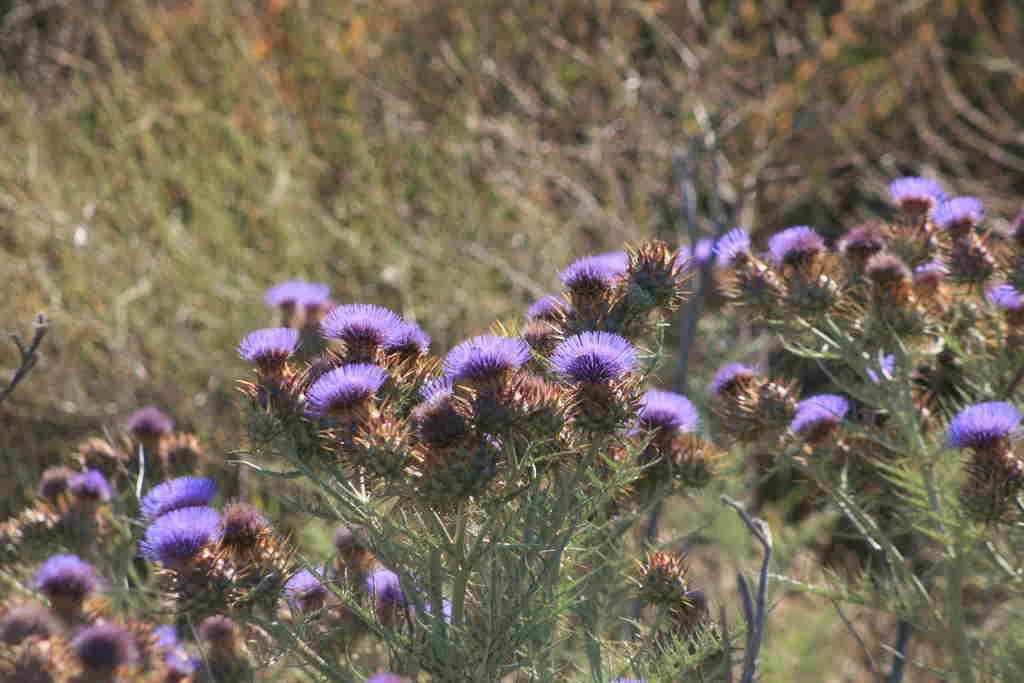What type of living organisms can be seen in the image? There are flowers and plants visible in the image. Can you describe the plants in the image? The plants in the image are not specified, but they are present alongside the flowers. What type of bone can be seen in the image? There is no bone present in the image; it features flowers and plants. How many horses are visible in the image? There are no horses present in the image; it features flowers and plants. 